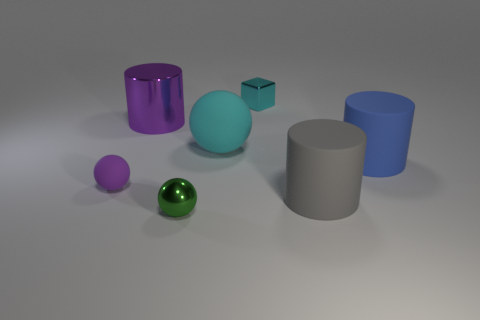How many gray rubber things have the same size as the blue thing?
Your response must be concise. 1. Is the big cylinder in front of the big blue object made of the same material as the tiny purple thing?
Your answer should be very brief. Yes. Is the number of metal cylinders that are on the right side of the large cyan thing less than the number of small metallic blocks?
Ensure brevity in your answer.  Yes. There is a rubber object that is to the left of the small green metallic thing; what is its shape?
Offer a terse response. Sphere. What shape is the purple thing that is the same size as the blue rubber cylinder?
Offer a very short reply. Cylinder. Is there a purple rubber thing that has the same shape as the cyan rubber thing?
Give a very brief answer. Yes. Does the big thing to the left of the large cyan object have the same shape as the rubber thing that is in front of the tiny purple ball?
Your response must be concise. Yes. There is a cyan object that is the same size as the purple matte thing; what is its material?
Give a very brief answer. Metal. How many other things are there of the same material as the cyan sphere?
Your response must be concise. 3. There is a purple thing to the right of the rubber thing left of the large cyan matte ball; what is its shape?
Provide a succinct answer. Cylinder. 